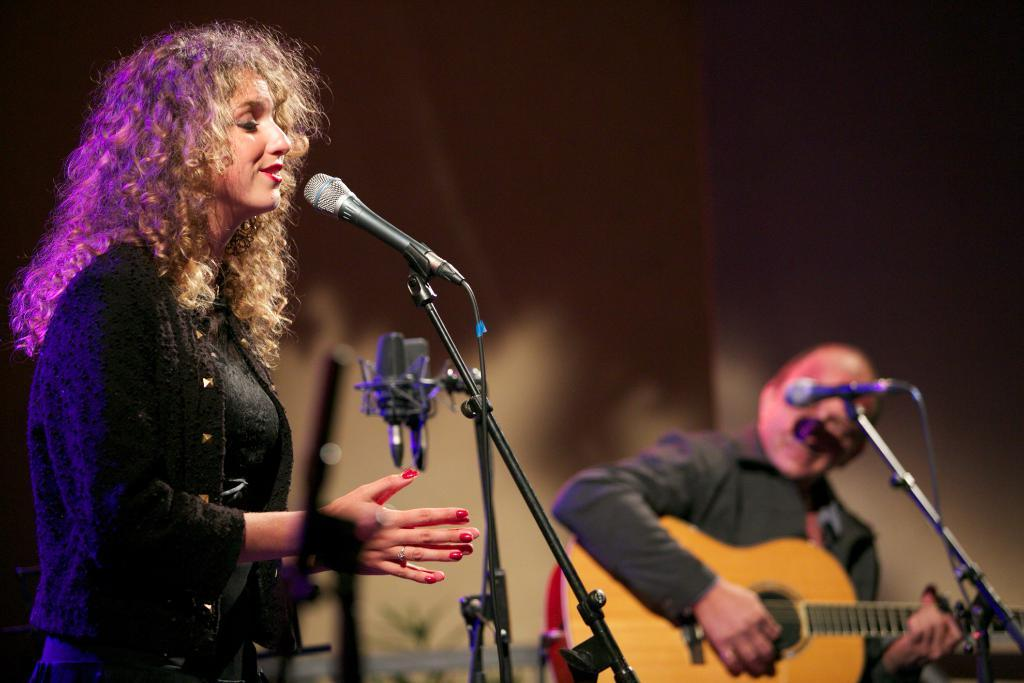What is the lady in the foreground of the image doing? The lady is singing in the foreground of the image. What is the lady holding while singing? The lady is holding a mic. What instrument can be seen being played in the background of the image? There is a person holding a guitar in the background of the image. Can you confirm the presence of a mic in the image? Yes, there is a mic in the image. What can be seen in the background of the image besides the person with the guitar? There is a wall in the background of the image. What type of watch is the lady wearing in the image? There is no watch visible on the lady in the image. Can you describe the base of the guitar being played in the image? There is no guitar base present in the image, as only the person holding the guitar is visible. 